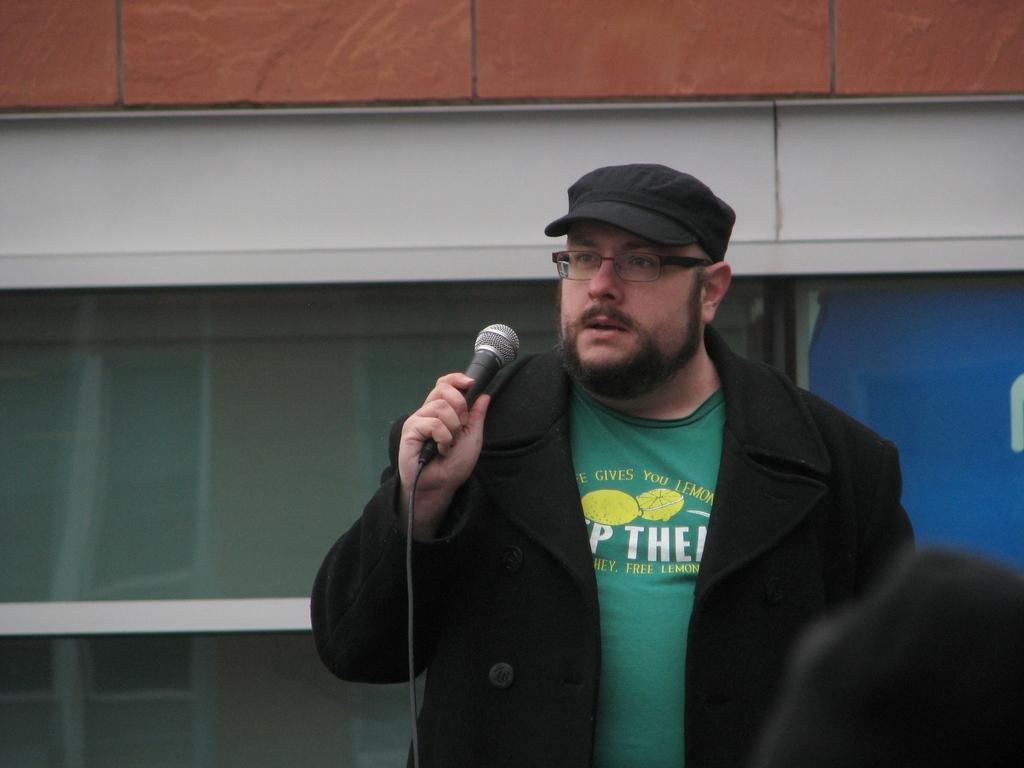How would you summarize this image in a sentence or two? In this picture we can see a man wearing a black colour blazer and a cap. He wore spectacles and he is holding a mike in his hand. 